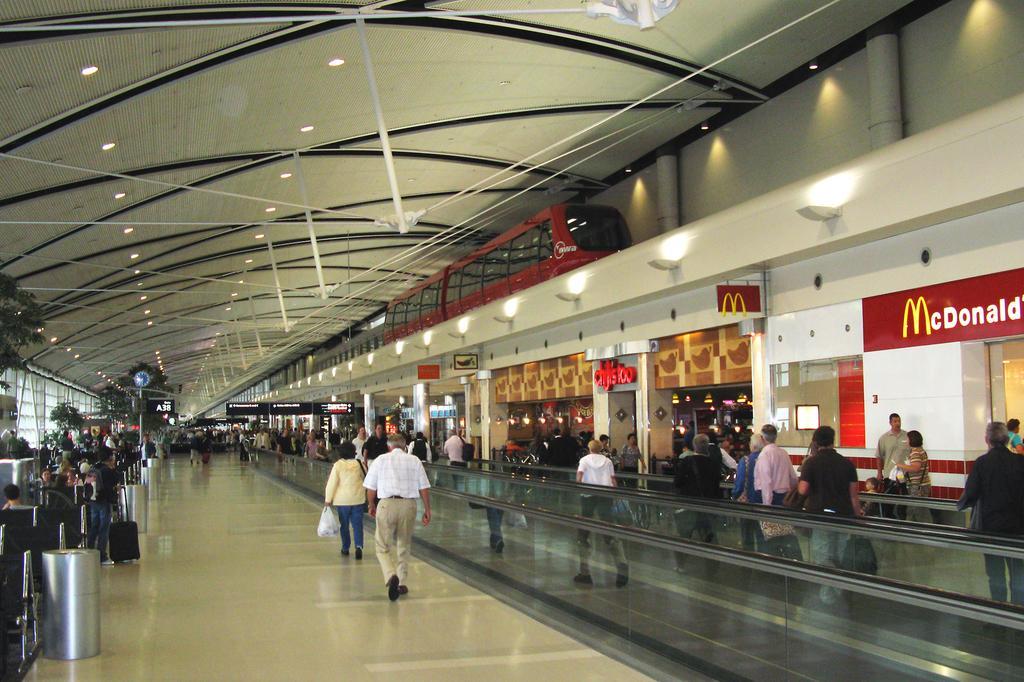Please provide a concise description of this image. In the middle of the image few people are standing and walking and holding some bags. Behind them there are some banners and there is fencing. At the top of the image there is wall and there is a locomotive. Behind the locomotive there is roof and lights. On the left side of the image there are some plants and poles. 